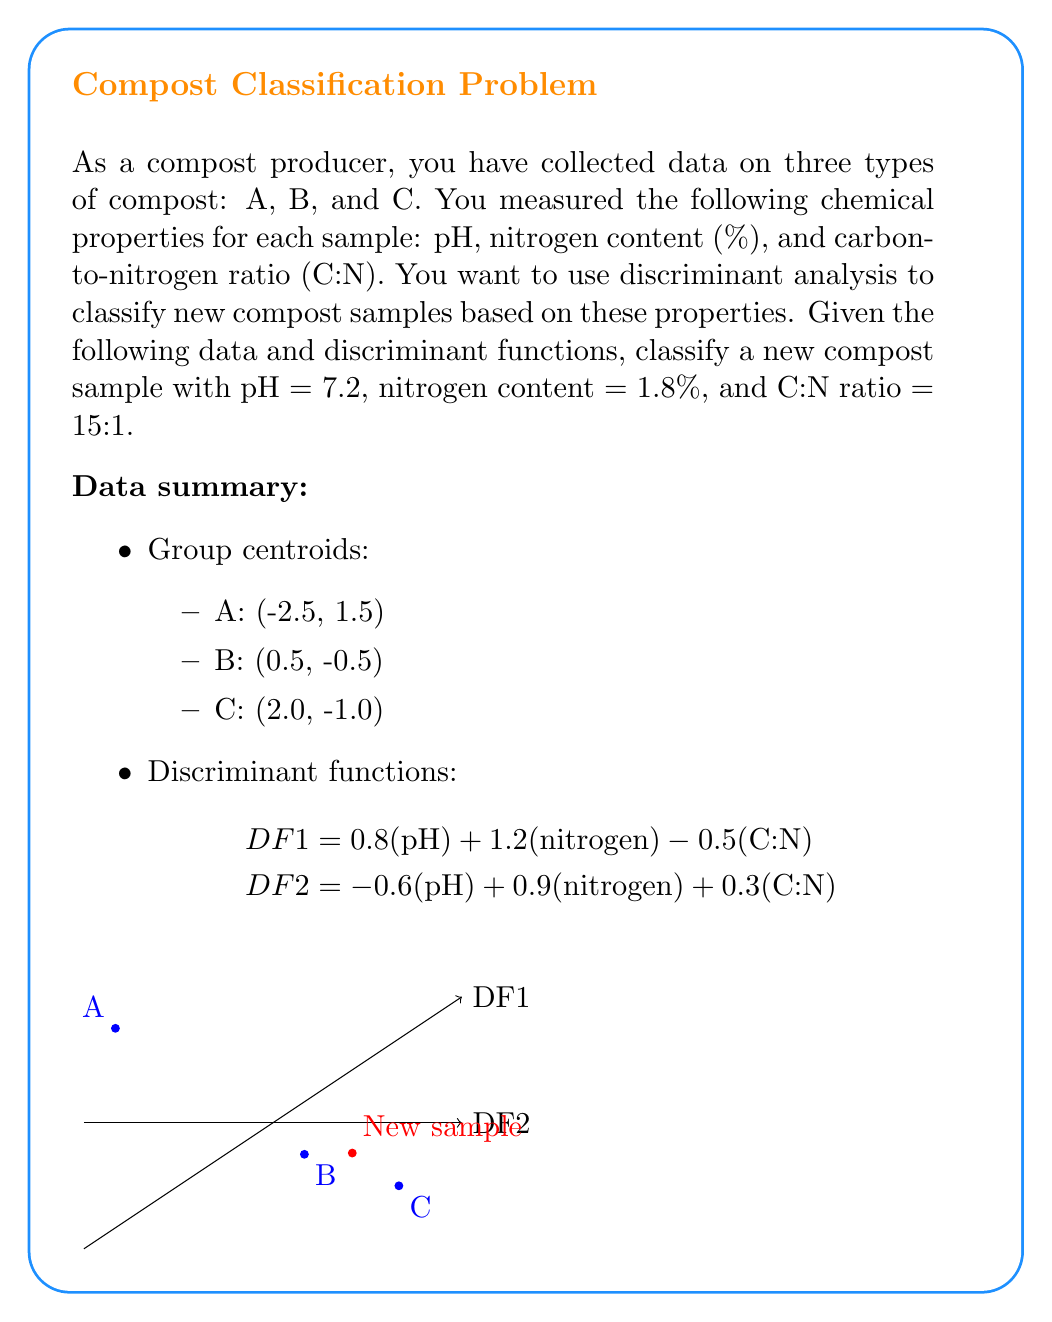What is the answer to this math problem? To classify the new compost sample using discriminant analysis, we need to follow these steps:

1. Calculate the discriminant function scores for the new sample:

   $$DF1 = 0.8(7.2) + 1.2(1.8) - 0.5(15) = 1.26$$
   $$DF2 = -0.6(7.2) + 0.9(1.8) + 0.3(15) = -0.48$$

2. Plot the new sample on the discriminant function space (shown in red on the graph).

3. Calculate the Euclidean distances between the new sample and each group centroid:

   Distance to A: $$\sqrt{(1.26 - (-2.5))^2 + (-0.48 - 1.5)^2} = 4.32$$
   Distance to B: $$\sqrt{(1.26 - 0.5)^2 + (-0.48 - (-0.5))^2} = 0.76$$
   Distance to C: $$\sqrt{(1.26 - 2.0)^2 + (-0.48 - (-1.0))^2} = 0.90$$

4. The new sample is classified into the group with the shortest distance.

The shortest distance is 0.76, which corresponds to group B.
Answer: Compost type B 